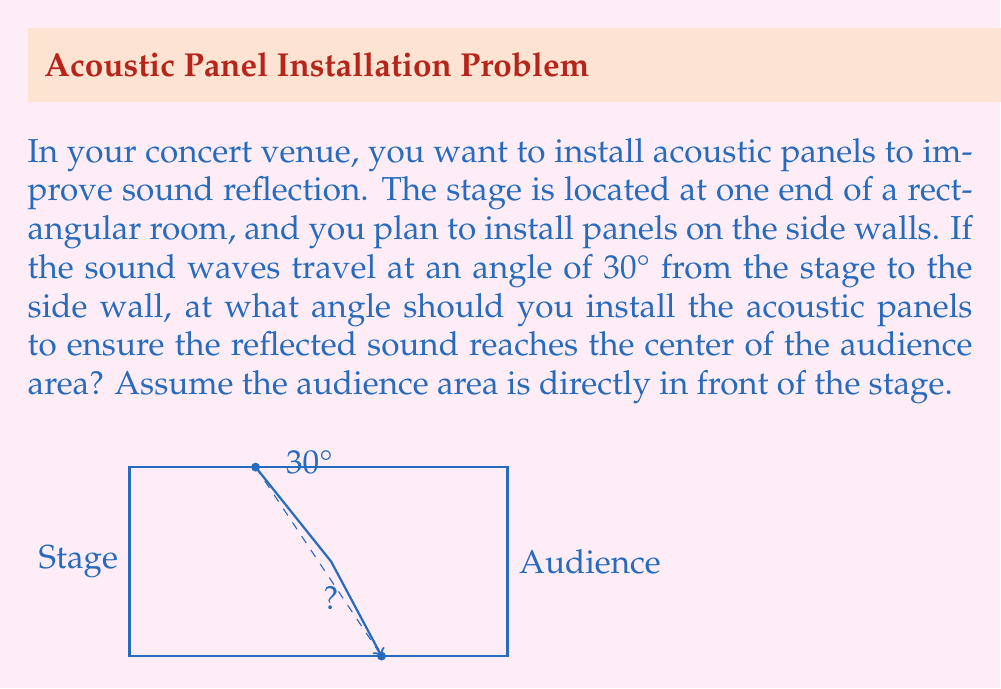Solve this math problem. To solve this problem, we'll use the law of reflection, which states that the angle of incidence equals the angle of reflection. Let's break it down step-by-step:

1) First, we need to understand that for the sound to reach the center of the audience after reflection, the total angle between the incident wave and the reflected wave should be 60°. This is because the incident wave is at 30° from the wall, and we want it to reflect back at 30° to reach the center of the audience.

2) Let's define θ as the angle between the acoustic panel and the wall.

3) The angle of incidence (i) with respect to the normal of the panel is:
   $i = 90° - (30° + θ)$

4) The angle of reflection (r) with respect to the normal of the panel is:
   $r = 90° - (30° - θ)$

5) According to the law of reflection, these angles should be equal:
   $i = r$
   $90° - (30° + θ) = 90° - (30° - θ)$

6) Simplifying:
   $-30° - θ = -30° + θ$
   $-θ = θ$
   $-2θ = 0$
   $θ = 0$

7) This means the acoustic panels should be installed parallel to the wall (at a 0° angle to the wall).

8) To verify: 
   - Incident angle to normal: $90° - (30° + 0°) = 60°$
   - Reflected angle to normal: $90° - (30° - 0°) = 60°$
   
   These are equal, confirming our solution.
Answer: 0° 